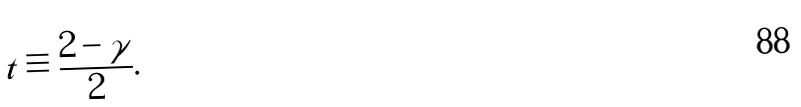<formula> <loc_0><loc_0><loc_500><loc_500>t \equiv \frac { 2 - \gamma } { 2 } .</formula> 